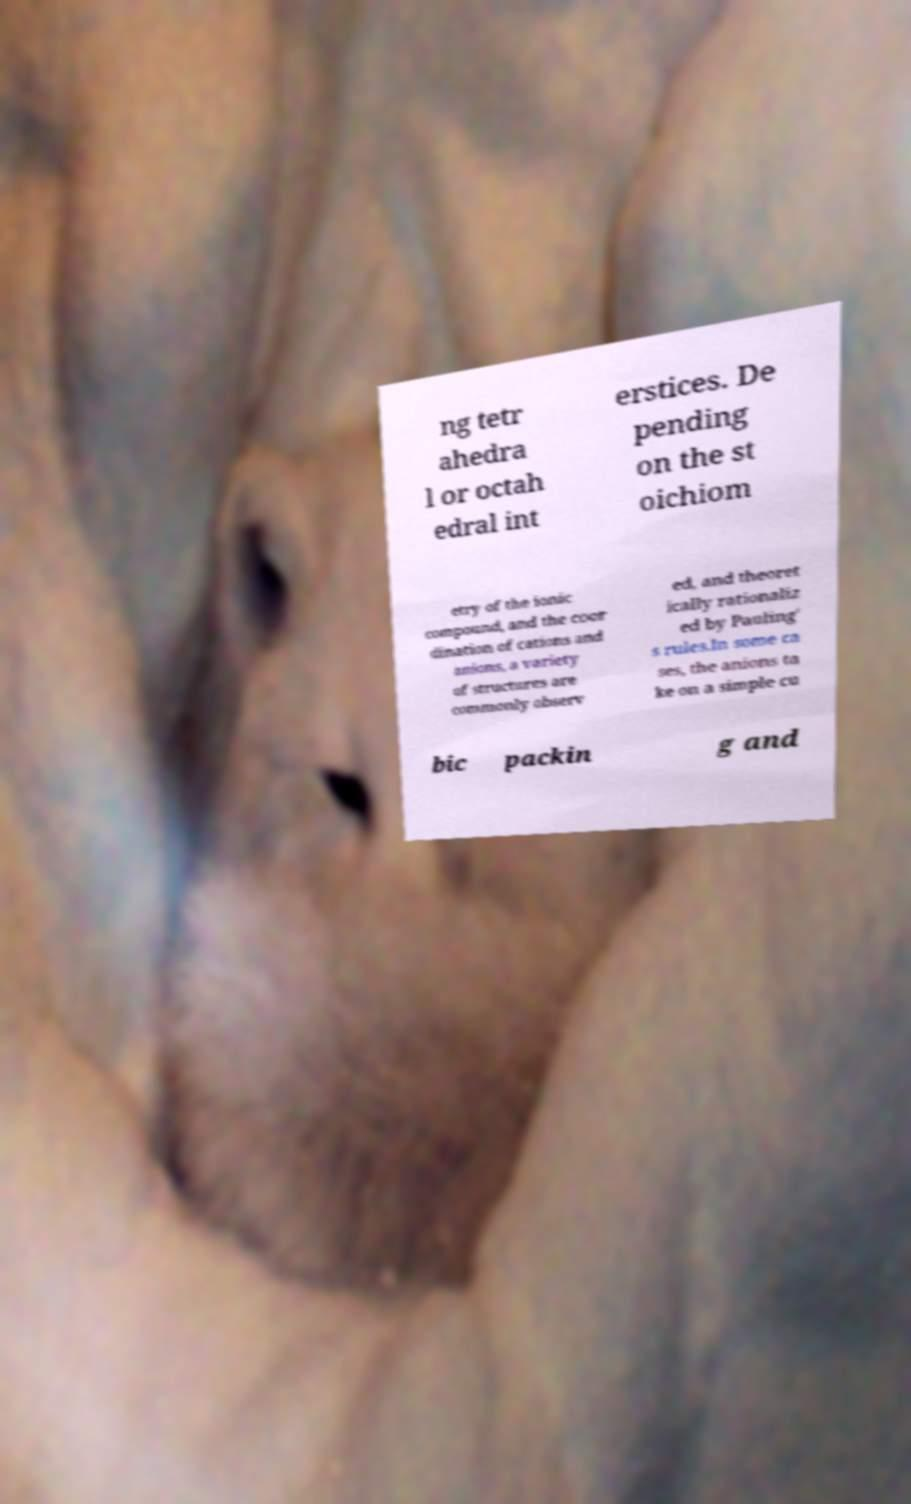Could you assist in decoding the text presented in this image and type it out clearly? ng tetr ahedra l or octah edral int erstices. De pending on the st oichiom etry of the ionic compound, and the coor dination of cations and anions, a variety of structures are commonly observ ed, and theoret ically rationaliz ed by Pauling' s rules.In some ca ses, the anions ta ke on a simple cu bic packin g and 